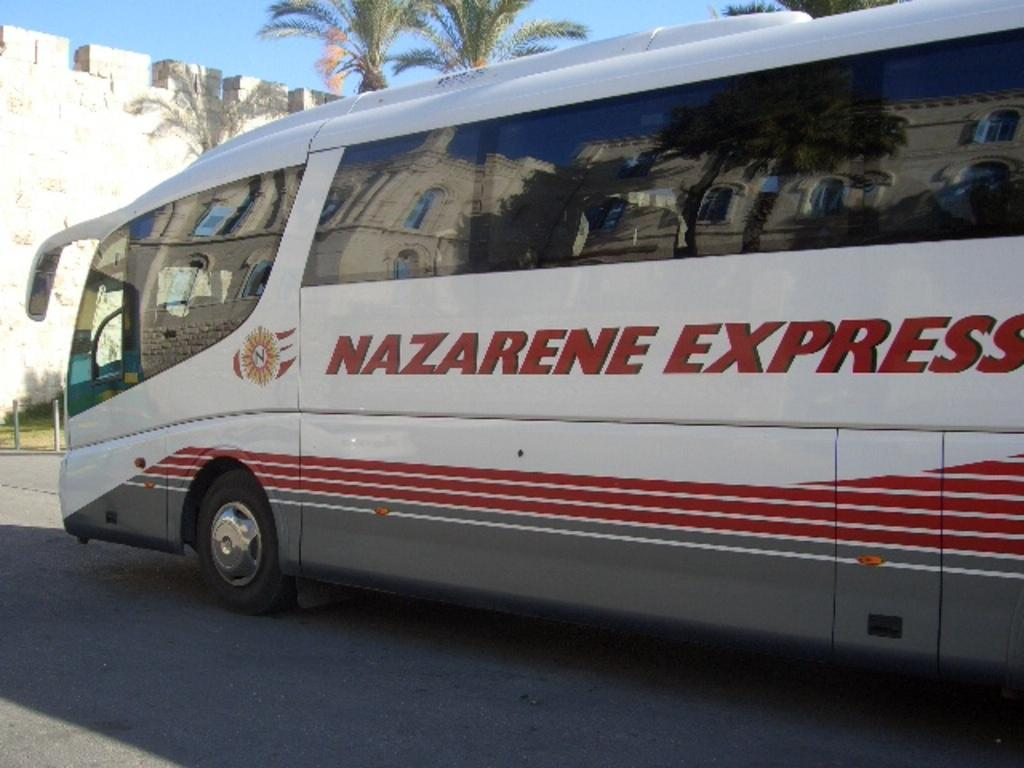<image>
Present a compact description of the photo's key features. A white bus that says Nazarene Express on the side of it. 